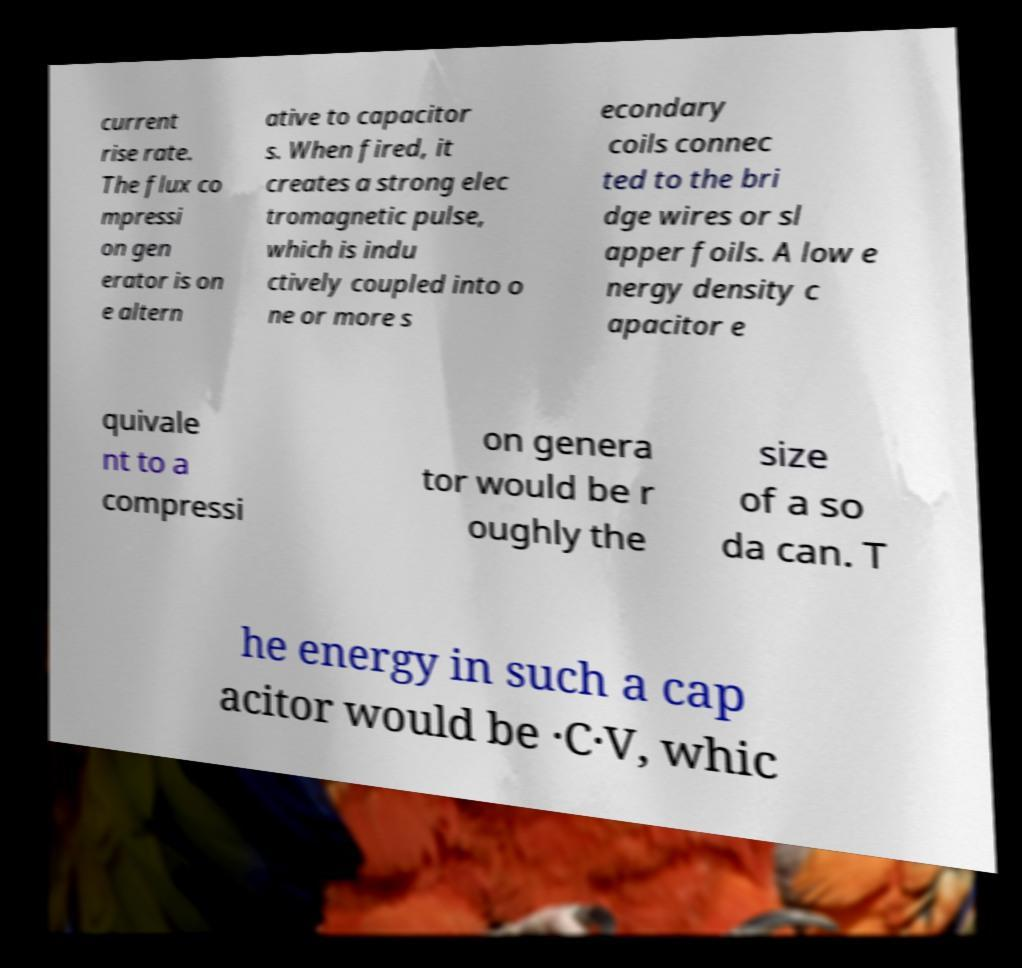I need the written content from this picture converted into text. Can you do that? current rise rate. The flux co mpressi on gen erator is on e altern ative to capacitor s. When fired, it creates a strong elec tromagnetic pulse, which is indu ctively coupled into o ne or more s econdary coils connec ted to the bri dge wires or sl apper foils. A low e nergy density c apacitor e quivale nt to a compressi on genera tor would be r oughly the size of a so da can. T he energy in such a cap acitor would be ·C·V, whic 